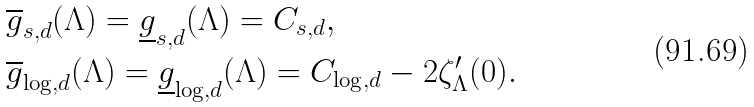Convert formula to latex. <formula><loc_0><loc_0><loc_500><loc_500>& \overline { g } _ { s , d } ( \Lambda ) = \underline { g } _ { s , d } ( \Lambda ) = C _ { s , d } , \\ & \overline { g } _ { \log , d } ( \Lambda ) = \underline { g } _ { \log , d } ( \Lambda ) = C _ { \log , d } - 2 \zeta ^ { \prime } _ { \Lambda } ( 0 ) .</formula> 